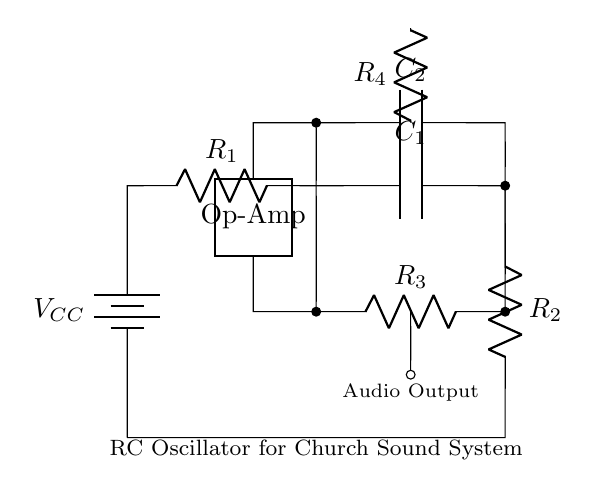What is the power source in this circuit? The circuit is powered by a battery labeled as VCC, which is the source of voltage and provides the necessary energy for the oscillator.
Answer: VCC How many resistors are in this circuit? There are four resistors in total: R1, R2, R3, and R4, which play crucial roles in controlling the oscillation frequency and gain.
Answer: Four What does C1 do in this circuit? C1 is a capacitor that, together with the resistors, helps determine the frequency of oscillation by charging and discharging at specific intervals.
Answer: Frequency determination Which component generates the audio output? The audio output is connected through R3 and is taken from the junction created in the oscillator, which converts the oscillations into an audio signal.
Answer: R3 What is the function of the operational amplifier in this circuit? The operational amplifier amplifies the signal generated by the RC network to strengthen the audio output before it is sent to the speaker or audio system.
Answer: Signal amplification What would happen to the frequency if R1 is increased? Increasing R1 would increase the time it takes for the capacitor to charge, thus lowering the frequency of the oscillation.
Answer: Frequency decreases What type of oscillator is shown in the diagram? The diagram represents an RC oscillator, specifically designed to generate audio frequencies for sound applications in church sound systems.
Answer: RC oscillator 